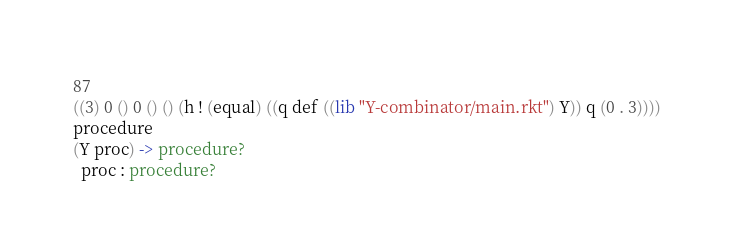Convert code to text. <code><loc_0><loc_0><loc_500><loc_500><_Racket_>87
((3) 0 () 0 () () (h ! (equal) ((q def ((lib "Y-combinator/main.rkt") Y)) q (0 . 3))))
procedure
(Y proc) -> procedure?
  proc : procedure?
</code> 